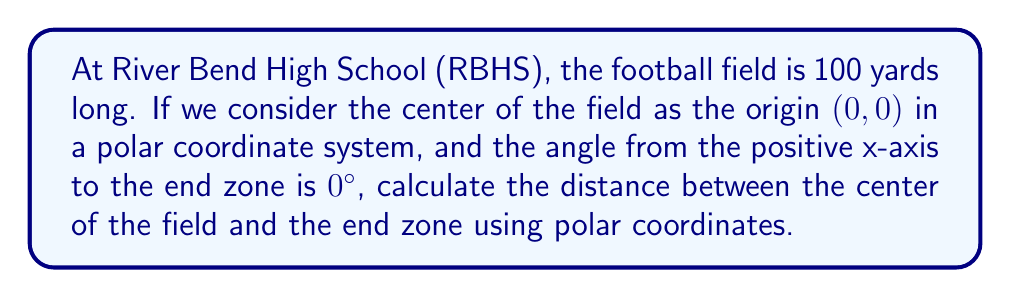Teach me how to tackle this problem. Let's approach this step-by-step:

1) In a standard American football field, the total length is 100 yards, with 50 yards on each side of the center.

2) The end zone is at the very end of the field, so we need to find the distance from the center to the end of the field.

3) In polar coordinates, we represent a point using the distance from the origin (r) and the angle from the positive x-axis (θ).

4) Given:
   - The center of the field is at (0,0)
   - The angle to the end zone is 0°
   - The distance to the end zone is half the field length

5) Calculate the distance (r):
   $$r = \frac{1}{2} \times 100 \text{ yards} = 50 \text{ yards}$$

6) The polar coordinates of the end zone are (50, 0°)

7) In polar form, this is written as:
   $$r = 50, \theta = 0°$$

[asy]
unitsize(4mm);
draw((-60,0)--(60,0),arrow=Arrow(TeXHead));
draw((0,-10)--(0,10),arrow=Arrow(TeXHead));
dot((50,0),red);
label("End zone",(50,0),N);
label("Center (0,0)",(0,0),SW);
label("50 yards",(25,0),S);
[/asy]

This diagram illustrates the football field with the center at the origin and the end zone 50 yards away along the x-axis.
Answer: The distance between the center of the football field and the end zone in polar coordinates is $r = 50$ yards at $\theta = 0°$. 